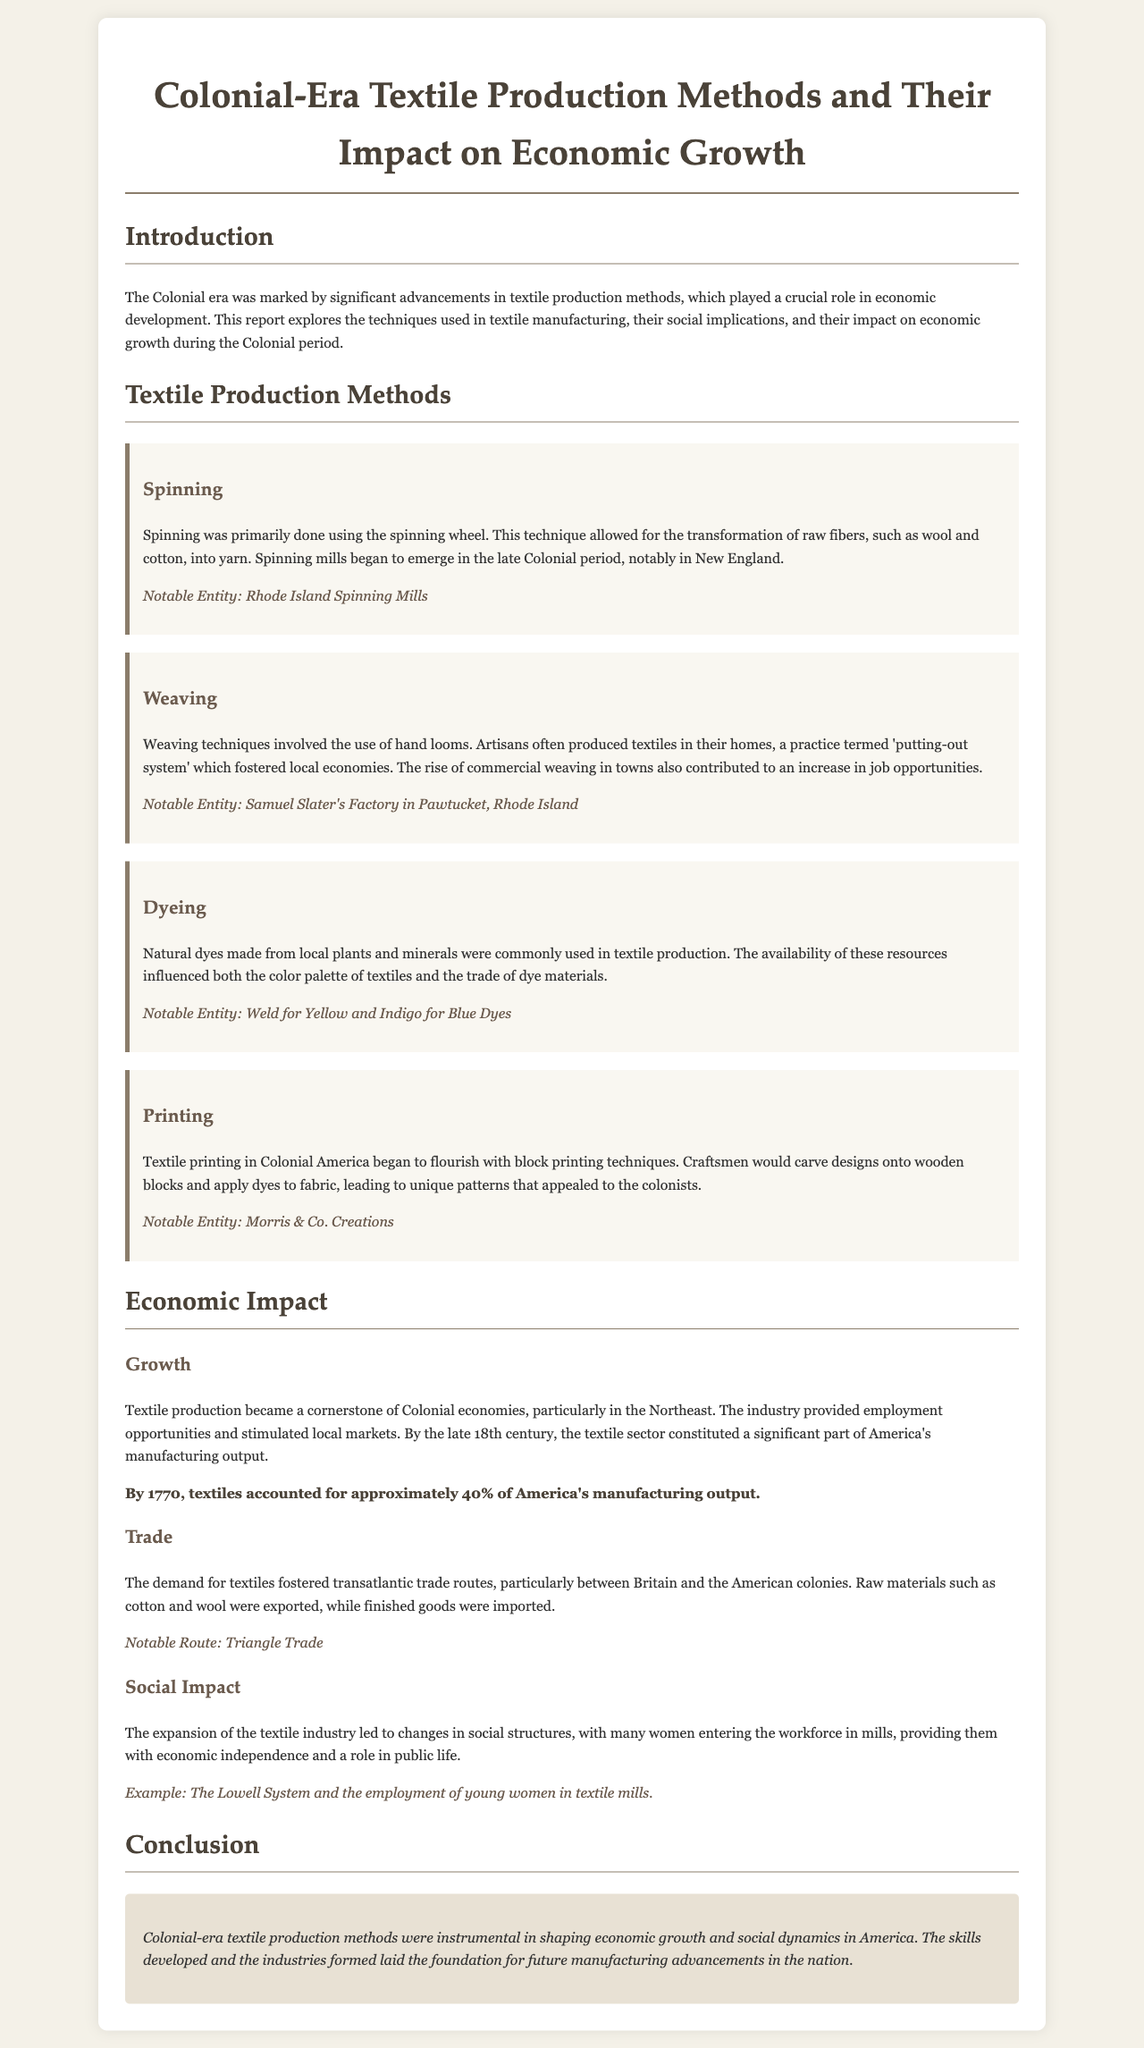what textile production technique utilized raw fibers? The document mentions that spinning was a technique that transformed raw fibers into yarn.
Answer: spinning which state was notable for the emergence of spinning mills? The report references Rhode Island as a notable state for spinning mills during the late Colonial period.
Answer: Rhode Island what color was commonly achieved using indigo dye? The document specifies that indigo dye was used to produce blue textiles.
Answer: blue what percentage of America's manufacturing output did textiles account for by 1770? The report states that by 1770, textiles accounted for approximately 40% of America's manufacturing output.
Answer: 40% which system provided employment for young women in textile mills? The document highlights the Lowell System as an example of providing employment for young women in the textile industry.
Answer: Lowell System what was the impact of textile production on local economies? The document explains that textile production provided employment opportunities and stimulated local markets, affecting economic growth.
Answer: employment opportunities name one notable route mentioned for the trade of textiles. The report cites the Triangle Trade as a notable route for textile trade.
Answer: Triangle Trade which technique led to unique patterns on textiles? The document indicates that block printing techniques led to unique patterns on textiles.
Answer: block printing what was a key social change due to the expansion of the textile industry? The report mentions that the expansion of the textile industry led to many women entering the workforce, contributing to economic independence.
Answer: economic independence 